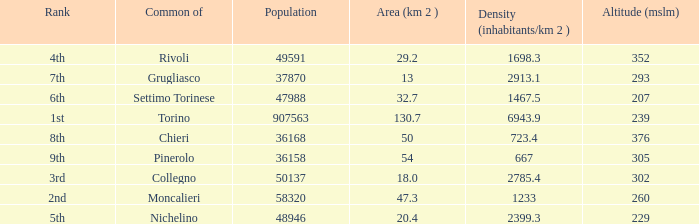How may population figures are given for Settimo Torinese 1.0. 